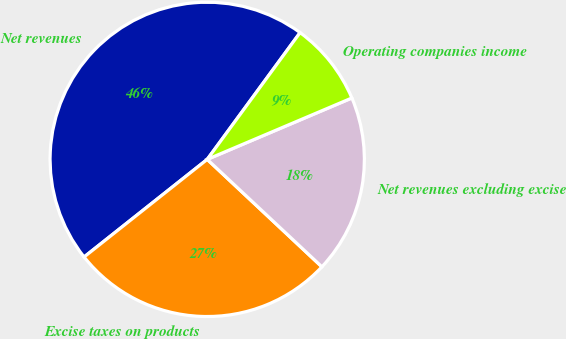<chart> <loc_0><loc_0><loc_500><loc_500><pie_chart><fcel>Net revenues<fcel>Excise taxes on products<fcel>Net revenues excluding excise<fcel>Operating companies income<nl><fcel>45.73%<fcel>27.35%<fcel>18.37%<fcel>8.55%<nl></chart> 